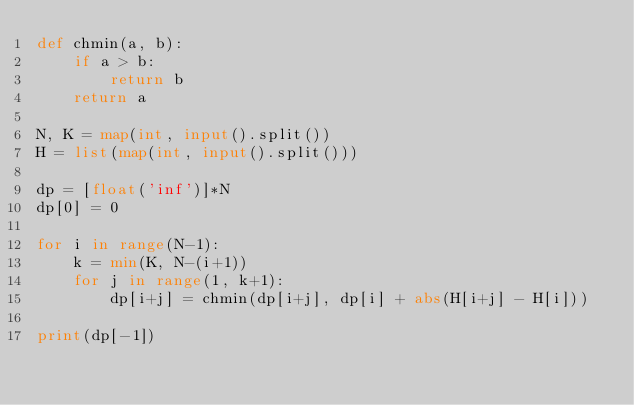<code> <loc_0><loc_0><loc_500><loc_500><_Python_>def chmin(a, b):
    if a > b:
        return b
    return a

N, K = map(int, input().split())
H = list(map(int, input().split()))

dp = [float('inf')]*N
dp[0] = 0

for i in range(N-1):
    k = min(K, N-(i+1))
    for j in range(1, k+1):
        dp[i+j] = chmin(dp[i+j], dp[i] + abs(H[i+j] - H[i]))

print(dp[-1])</code> 